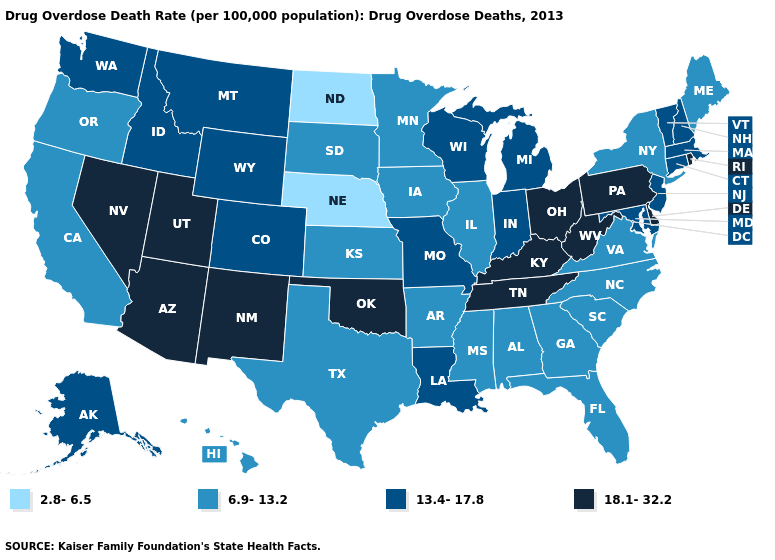Among the states that border West Virginia , which have the highest value?
Answer briefly. Kentucky, Ohio, Pennsylvania. What is the highest value in the USA?
Short answer required. 18.1-32.2. Name the states that have a value in the range 13.4-17.8?
Give a very brief answer. Alaska, Colorado, Connecticut, Idaho, Indiana, Louisiana, Maryland, Massachusetts, Michigan, Missouri, Montana, New Hampshire, New Jersey, Vermont, Washington, Wisconsin, Wyoming. Does Nebraska have the same value as North Dakota?
Give a very brief answer. Yes. Among the states that border West Virginia , does Virginia have the highest value?
Concise answer only. No. Is the legend a continuous bar?
Be succinct. No. Name the states that have a value in the range 2.8-6.5?
Answer briefly. Nebraska, North Dakota. Is the legend a continuous bar?
Answer briefly. No. Does Massachusetts have a higher value than Nevada?
Concise answer only. No. Name the states that have a value in the range 13.4-17.8?
Short answer required. Alaska, Colorado, Connecticut, Idaho, Indiana, Louisiana, Maryland, Massachusetts, Michigan, Missouri, Montana, New Hampshire, New Jersey, Vermont, Washington, Wisconsin, Wyoming. Name the states that have a value in the range 6.9-13.2?
Be succinct. Alabama, Arkansas, California, Florida, Georgia, Hawaii, Illinois, Iowa, Kansas, Maine, Minnesota, Mississippi, New York, North Carolina, Oregon, South Carolina, South Dakota, Texas, Virginia. Name the states that have a value in the range 18.1-32.2?
Be succinct. Arizona, Delaware, Kentucky, Nevada, New Mexico, Ohio, Oklahoma, Pennsylvania, Rhode Island, Tennessee, Utah, West Virginia. Name the states that have a value in the range 18.1-32.2?
Quick response, please. Arizona, Delaware, Kentucky, Nevada, New Mexico, Ohio, Oklahoma, Pennsylvania, Rhode Island, Tennessee, Utah, West Virginia. What is the value of Rhode Island?
Concise answer only. 18.1-32.2. 